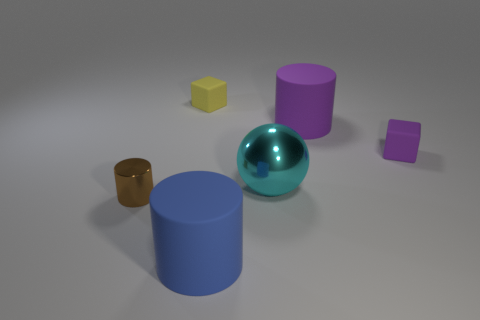Add 1 big purple things. How many objects exist? 7 Subtract all spheres. How many objects are left? 5 Add 1 blue matte things. How many blue matte things are left? 2 Add 3 green cylinders. How many green cylinders exist? 3 Subtract 0 red cylinders. How many objects are left? 6 Subtract all large blue cylinders. Subtract all rubber cubes. How many objects are left? 3 